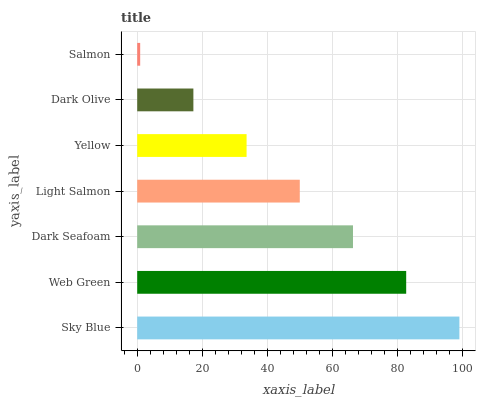Is Salmon the minimum?
Answer yes or no. Yes. Is Sky Blue the maximum?
Answer yes or no. Yes. Is Web Green the minimum?
Answer yes or no. No. Is Web Green the maximum?
Answer yes or no. No. Is Sky Blue greater than Web Green?
Answer yes or no. Yes. Is Web Green less than Sky Blue?
Answer yes or no. Yes. Is Web Green greater than Sky Blue?
Answer yes or no. No. Is Sky Blue less than Web Green?
Answer yes or no. No. Is Light Salmon the high median?
Answer yes or no. Yes. Is Light Salmon the low median?
Answer yes or no. Yes. Is Web Green the high median?
Answer yes or no. No. Is Sky Blue the low median?
Answer yes or no. No. 